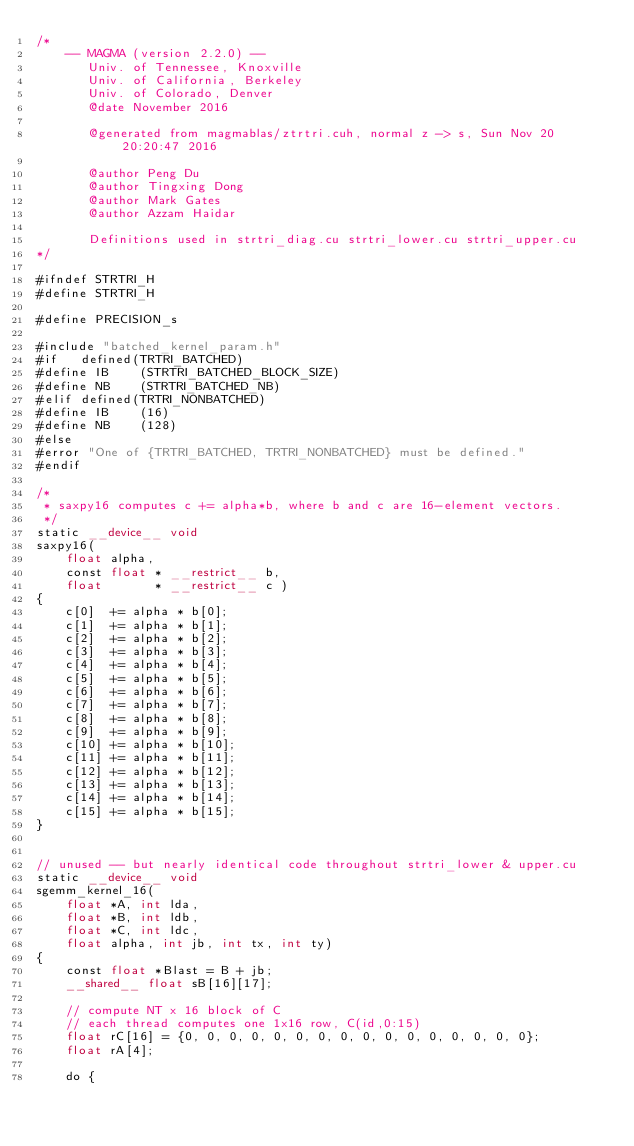<code> <loc_0><loc_0><loc_500><loc_500><_Cuda_>/*
    -- MAGMA (version 2.2.0) --
       Univ. of Tennessee, Knoxville
       Univ. of California, Berkeley
       Univ. of Colorado, Denver
       @date November 2016

       @generated from magmablas/ztrtri.cuh, normal z -> s, Sun Nov 20 20:20:47 2016

       @author Peng Du
       @author Tingxing Dong
       @author Mark Gates
       @author Azzam Haidar
       
       Definitions used in strtri_diag.cu strtri_lower.cu strtri_upper.cu
*/

#ifndef STRTRI_H
#define STRTRI_H

#define PRECISION_s 

#include "batched_kernel_param.h"
#if   defined(TRTRI_BATCHED)
#define IB    (STRTRI_BATCHED_BLOCK_SIZE)
#define NB    (STRTRI_BATCHED_NB)
#elif defined(TRTRI_NONBATCHED)
#define IB    (16)
#define NB    (128)
#else
#error "One of {TRTRI_BATCHED, TRTRI_NONBATCHED} must be defined."
#endif

/*
 * saxpy16 computes c += alpha*b, where b and c are 16-element vectors.
 */
static __device__ void
saxpy16(
    float alpha,
    const float * __restrict__ b,
    float       * __restrict__ c )
{
    c[0]  += alpha * b[0];
    c[1]  += alpha * b[1];
    c[2]  += alpha * b[2];
    c[3]  += alpha * b[3];
    c[4]  += alpha * b[4];
    c[5]  += alpha * b[5];
    c[6]  += alpha * b[6];
    c[7]  += alpha * b[7];
    c[8]  += alpha * b[8];
    c[9]  += alpha * b[9];
    c[10] += alpha * b[10];
    c[11] += alpha * b[11];
    c[12] += alpha * b[12];
    c[13] += alpha * b[13];
    c[14] += alpha * b[14];
    c[15] += alpha * b[15];
}


// unused -- but nearly identical code throughout strtri_lower & upper.cu
static __device__ void
sgemm_kernel_16(
    float *A, int lda,
    float *B, int ldb,
    float *C, int ldc,
    float alpha, int jb, int tx, int ty)
{
    const float *Blast = B + jb;
    __shared__ float sB[16][17];
    
    // compute NT x 16 block of C
    // each thread computes one 1x16 row, C(id,0:15)
    float rC[16] = {0, 0, 0, 0, 0, 0, 0, 0, 0, 0, 0, 0, 0, 0, 0, 0};
    float rA[4];

    do {</code> 